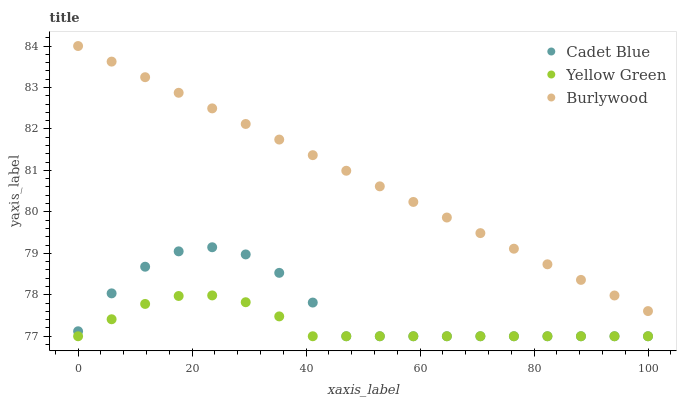Does Yellow Green have the minimum area under the curve?
Answer yes or no. Yes. Does Burlywood have the maximum area under the curve?
Answer yes or no. Yes. Does Cadet Blue have the minimum area under the curve?
Answer yes or no. No. Does Cadet Blue have the maximum area under the curve?
Answer yes or no. No. Is Burlywood the smoothest?
Answer yes or no. Yes. Is Cadet Blue the roughest?
Answer yes or no. Yes. Is Yellow Green the smoothest?
Answer yes or no. No. Is Yellow Green the roughest?
Answer yes or no. No. Does Cadet Blue have the lowest value?
Answer yes or no. Yes. Does Burlywood have the highest value?
Answer yes or no. Yes. Does Cadet Blue have the highest value?
Answer yes or no. No. Is Yellow Green less than Burlywood?
Answer yes or no. Yes. Is Burlywood greater than Cadet Blue?
Answer yes or no. Yes. Does Cadet Blue intersect Yellow Green?
Answer yes or no. Yes. Is Cadet Blue less than Yellow Green?
Answer yes or no. No. Is Cadet Blue greater than Yellow Green?
Answer yes or no. No. Does Yellow Green intersect Burlywood?
Answer yes or no. No. 